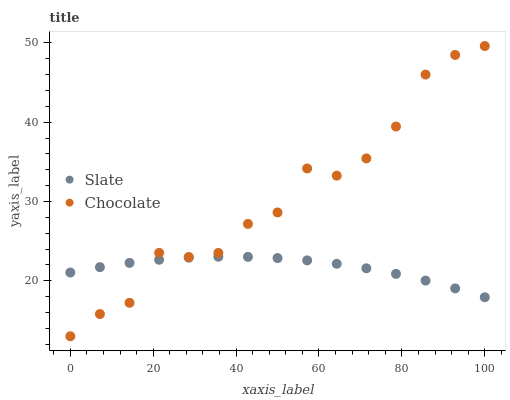Does Slate have the minimum area under the curve?
Answer yes or no. Yes. Does Chocolate have the maximum area under the curve?
Answer yes or no. Yes. Does Chocolate have the minimum area under the curve?
Answer yes or no. No. Is Slate the smoothest?
Answer yes or no. Yes. Is Chocolate the roughest?
Answer yes or no. Yes. Is Chocolate the smoothest?
Answer yes or no. No. Does Chocolate have the lowest value?
Answer yes or no. Yes. Does Chocolate have the highest value?
Answer yes or no. Yes. Does Slate intersect Chocolate?
Answer yes or no. Yes. Is Slate less than Chocolate?
Answer yes or no. No. Is Slate greater than Chocolate?
Answer yes or no. No. 